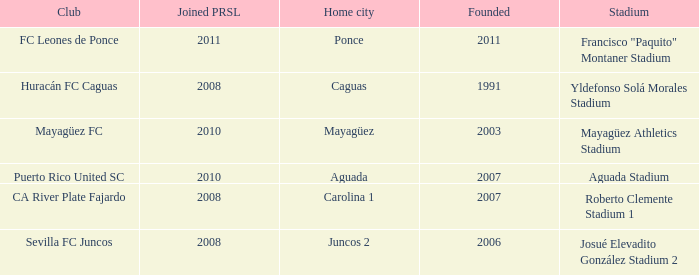What is the earliest founded when the home city is mayagüez? 2003.0. 